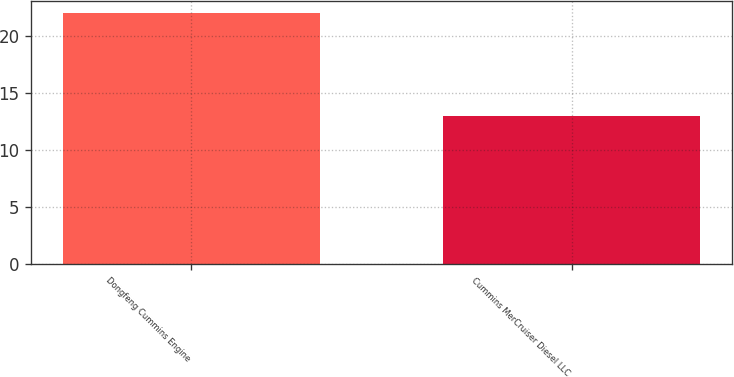Convert chart to OTSL. <chart><loc_0><loc_0><loc_500><loc_500><bar_chart><fcel>Dongfeng Cummins Engine<fcel>Cummins MerCruiser Diesel LLC<nl><fcel>22<fcel>13<nl></chart> 